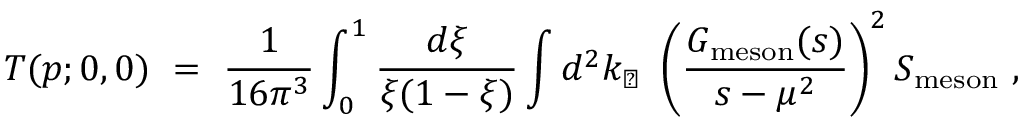<formula> <loc_0><loc_0><loc_500><loc_500>T ( p ; 0 , 0 ) \ = \ \frac { 1 } 1 6 \pi ^ { 3 } } \int _ { 0 } ^ { 1 } \frac { d \xi } { \xi ( 1 - \xi ) } \int d ^ { 2 } k _ { \perp } \ \left ( \frac { G _ { m e s o n } ( s ) } { s - \mu ^ { 2 } } \right ) ^ { 2 } S _ { m e s o n } \ ,</formula> 